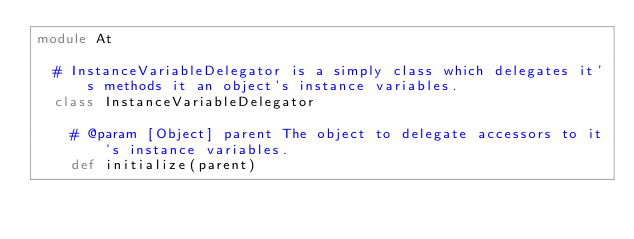Convert code to text. <code><loc_0><loc_0><loc_500><loc_500><_Ruby_>module At
  
  # InstanceVariableDelegator is a simply class which delegates it's methods it an object's instance variables.
  class InstanceVariableDelegator
    
    # @param [Object] parent The object to delegate accessors to it's instance variables.
    def initialize(parent)</code> 